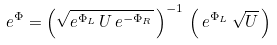<formula> <loc_0><loc_0><loc_500><loc_500>e ^ { \Phi } = \left ( \sqrt { e ^ { \Phi _ { L } } \, U \, e ^ { - \Phi _ { R } } } \, \right ) ^ { - 1 } \, \left ( \, e ^ { \Phi _ { L } } \, \sqrt { U } \, \right )</formula> 